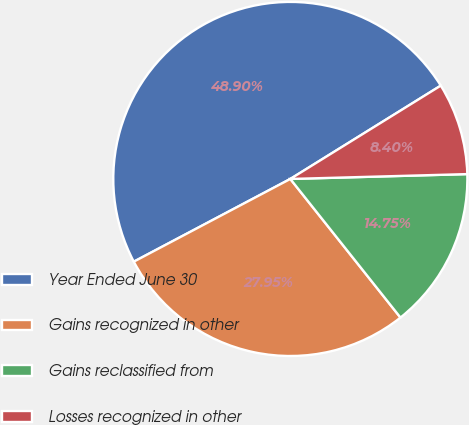<chart> <loc_0><loc_0><loc_500><loc_500><pie_chart><fcel>Year Ended June 30<fcel>Gains recognized in other<fcel>Gains reclassified from<fcel>Losses recognized in other<nl><fcel>48.9%<fcel>27.95%<fcel>14.75%<fcel>8.4%<nl></chart> 